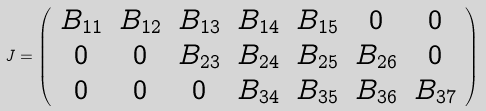Convert formula to latex. <formula><loc_0><loc_0><loc_500><loc_500>J = \left ( \begin{array} { c c c c c c c } B _ { 1 1 } & B _ { 1 2 } & B _ { 1 3 } & B _ { 1 4 } & B _ { 1 5 } & 0 & 0 \\ 0 & 0 & B _ { 2 3 } & B _ { 2 4 } & B _ { 2 5 } & B _ { 2 6 } & 0 \\ 0 & 0 & 0 & B _ { 3 4 } & B _ { 3 5 } & B _ { 3 6 } & B _ { 3 7 } \end{array} \right )</formula> 